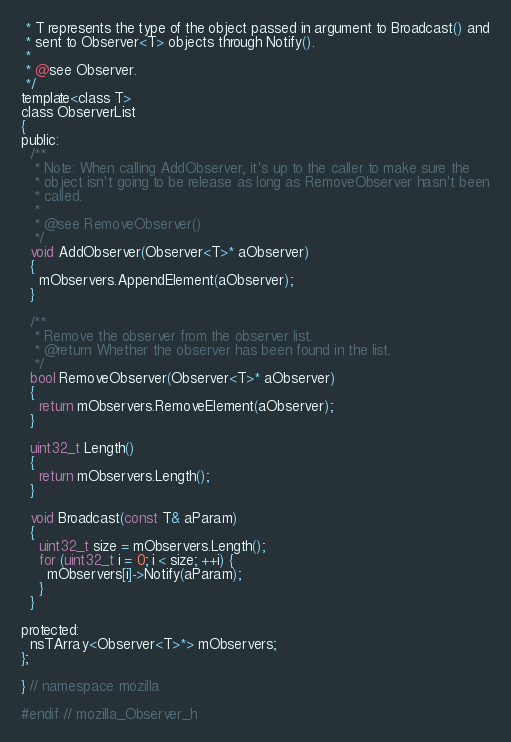Convert code to text. <code><loc_0><loc_0><loc_500><loc_500><_C_> * T represents the type of the object passed in argument to Broadcast() and
 * sent to Observer<T> objects through Notify().
 *
 * @see Observer.
 */
template<class T>
class ObserverList
{
public:
  /**
   * Note: When calling AddObserver, it's up to the caller to make sure the
   * object isn't going to be release as long as RemoveObserver hasn't been
   * called.
   *
   * @see RemoveObserver()
   */
  void AddObserver(Observer<T>* aObserver)
  {
    mObservers.AppendElement(aObserver);
  }

  /**
   * Remove the observer from the observer list.
   * @return Whether the observer has been found in the list.
   */
  bool RemoveObserver(Observer<T>* aObserver)
  {
    return mObservers.RemoveElement(aObserver);
  }

  uint32_t Length()
  {
    return mObservers.Length();
  }

  void Broadcast(const T& aParam)
  {
    uint32_t size = mObservers.Length();
    for (uint32_t i = 0; i < size; ++i) {
      mObservers[i]->Notify(aParam);
    }
  }

protected:
  nsTArray<Observer<T>*> mObservers;
};

} // namespace mozilla

#endif // mozilla_Observer_h
</code> 